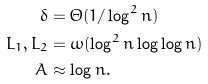Convert formula to latex. <formula><loc_0><loc_0><loc_500><loc_500>\delta & = \Theta ( 1 / \log ^ { 2 } n ) \\ L _ { 1 } , L _ { 2 } & = \omega ( \log ^ { 2 } n \log \log n ) \\ A & \approx \log n .</formula> 